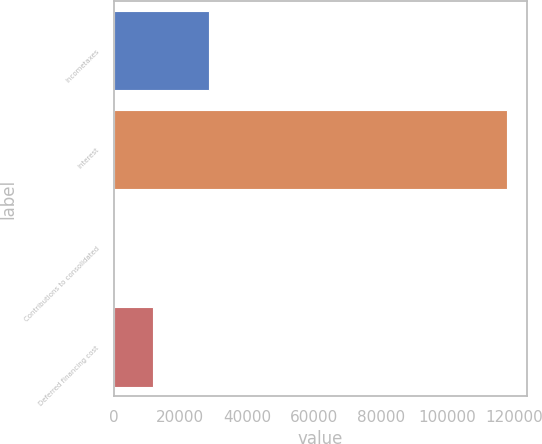Convert chart to OTSL. <chart><loc_0><loc_0><loc_500><loc_500><bar_chart><fcel>Incometaxes<fcel>Interest<fcel>Contributions to consolidated<fcel>Deferred financing cost<nl><fcel>28585<fcel>117856<fcel>25<fcel>11808.1<nl></chart> 